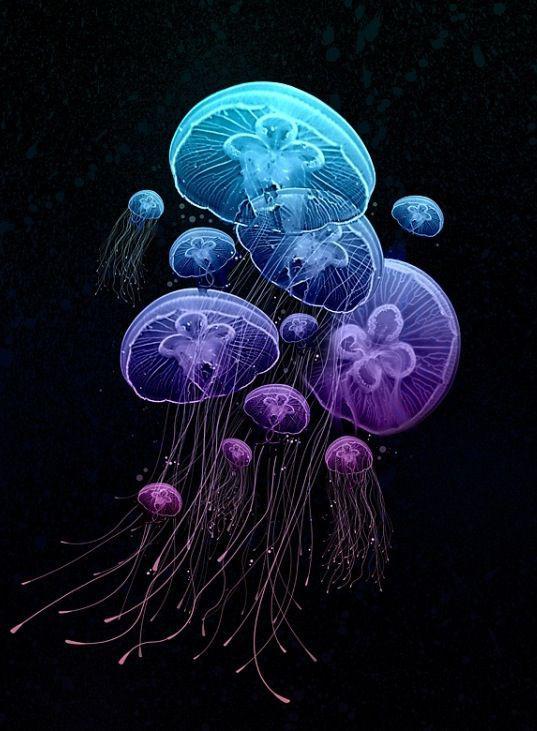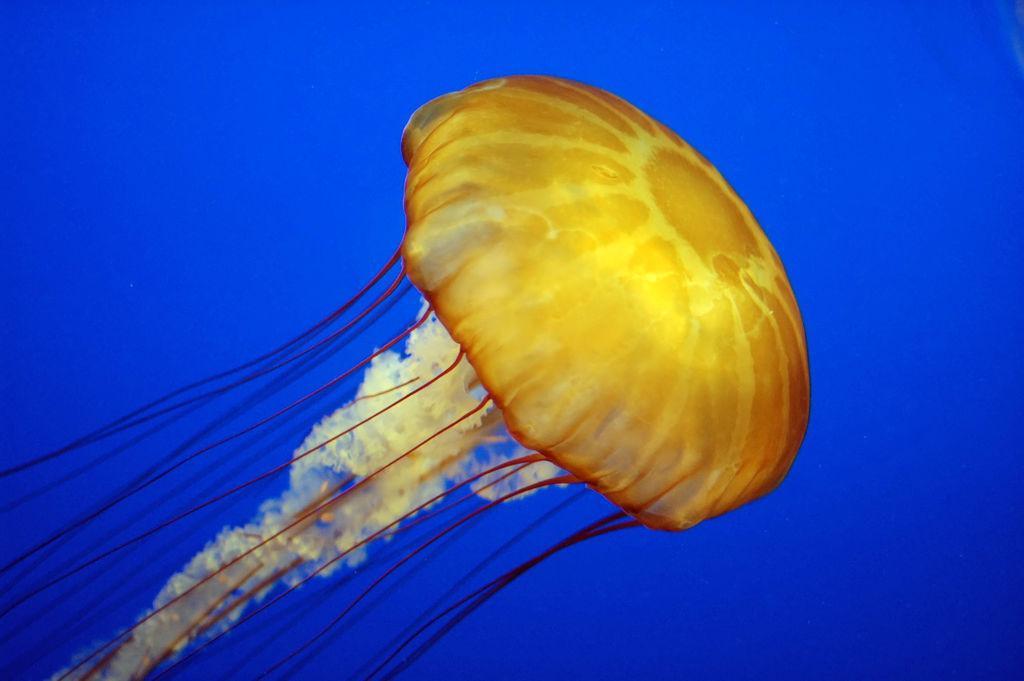The first image is the image on the left, the second image is the image on the right. Evaluate the accuracy of this statement regarding the images: "There is a warm-coloured jellyfish in the right image with a darker blue almost solid water background.". Is it true? Answer yes or no. Yes. 